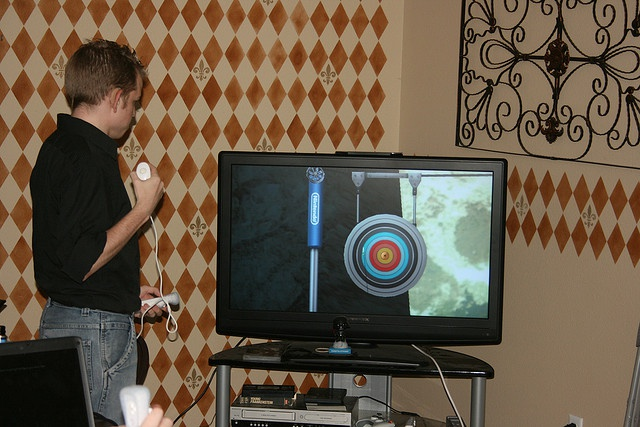Describe the objects in this image and their specific colors. I can see tv in maroon, black, gray, darkgray, and lightblue tones, people in maroon, black, and gray tones, laptop in maroon, black, and gray tones, remote in maroon, darkgray, gray, and lightgray tones, and remote in maroon, lightgray, darkgray, and gray tones in this image. 